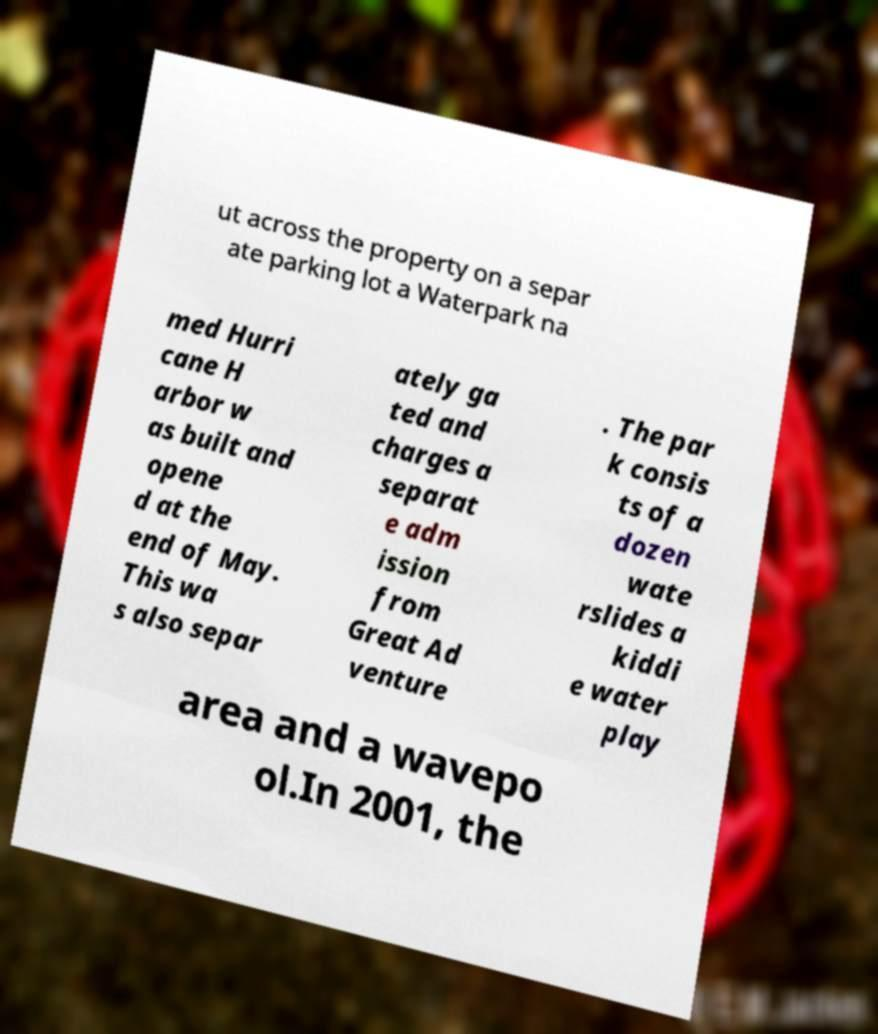What messages or text are displayed in this image? I need them in a readable, typed format. ut across the property on a separ ate parking lot a Waterpark na med Hurri cane H arbor w as built and opene d at the end of May. This wa s also separ ately ga ted and charges a separat e adm ission from Great Ad venture . The par k consis ts of a dozen wate rslides a kiddi e water play area and a wavepo ol.In 2001, the 